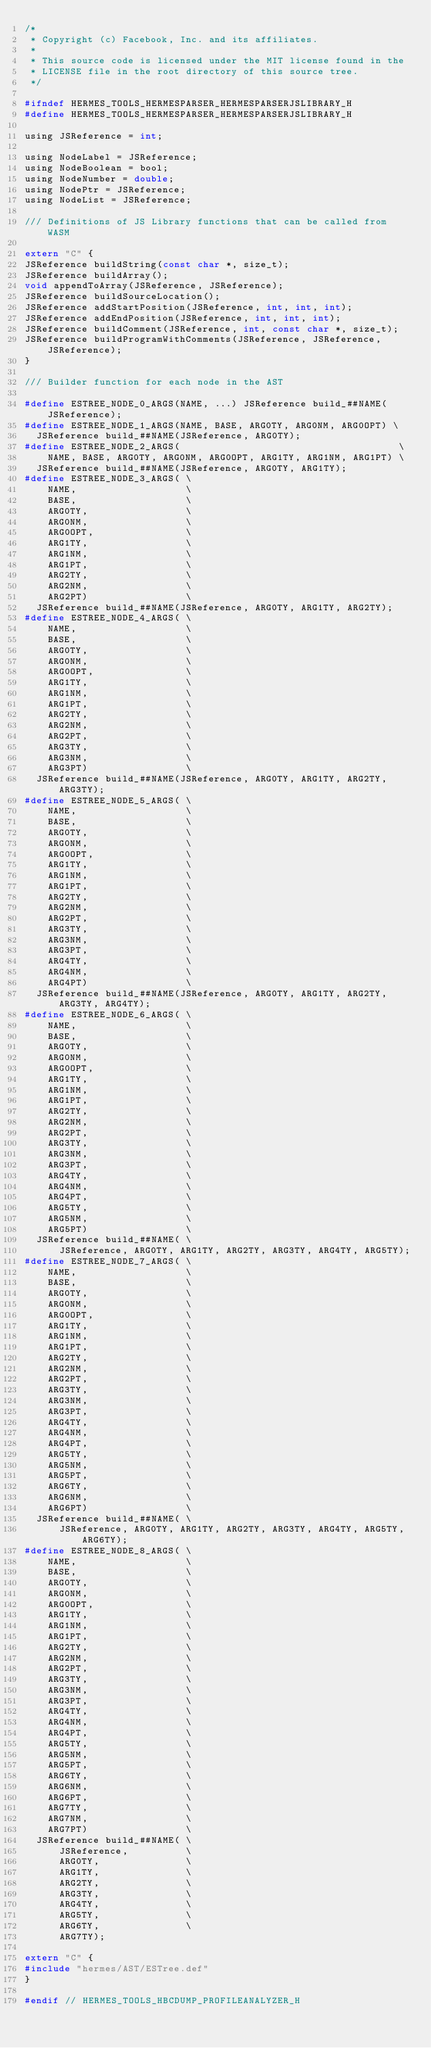Convert code to text. <code><loc_0><loc_0><loc_500><loc_500><_C_>/*
 * Copyright (c) Facebook, Inc. and its affiliates.
 *
 * This source code is licensed under the MIT license found in the
 * LICENSE file in the root directory of this source tree.
 */

#ifndef HERMES_TOOLS_HERMESPARSER_HERMESPARSERJSLIBRARY_H
#define HERMES_TOOLS_HERMESPARSER_HERMESPARSERJSLIBRARY_H

using JSReference = int;

using NodeLabel = JSReference;
using NodeBoolean = bool;
using NodeNumber = double;
using NodePtr = JSReference;
using NodeList = JSReference;

/// Definitions of JS Library functions that can be called from WASM

extern "C" {
JSReference buildString(const char *, size_t);
JSReference buildArray();
void appendToArray(JSReference, JSReference);
JSReference buildSourceLocation();
JSReference addStartPosition(JSReference, int, int, int);
JSReference addEndPosition(JSReference, int, int, int);
JSReference buildComment(JSReference, int, const char *, size_t);
JSReference buildProgramWithComments(JSReference, JSReference, JSReference);
}

/// Builder function for each node in the AST

#define ESTREE_NODE_0_ARGS(NAME, ...) JSReference build_##NAME(JSReference);
#define ESTREE_NODE_1_ARGS(NAME, BASE, ARG0TY, ARG0NM, ARG0OPT) \
  JSReference build_##NAME(JSReference, ARG0TY);
#define ESTREE_NODE_2_ARGS(                                      \
    NAME, BASE, ARG0TY, ARG0NM, ARG0OPT, ARG1TY, ARG1NM, ARG1PT) \
  JSReference build_##NAME(JSReference, ARG0TY, ARG1TY);
#define ESTREE_NODE_3_ARGS( \
    NAME,                   \
    BASE,                   \
    ARG0TY,                 \
    ARG0NM,                 \
    ARG0OPT,                \
    ARG1TY,                 \
    ARG1NM,                 \
    ARG1PT,                 \
    ARG2TY,                 \
    ARG2NM,                 \
    ARG2PT)                 \
  JSReference build_##NAME(JSReference, ARG0TY, ARG1TY, ARG2TY);
#define ESTREE_NODE_4_ARGS( \
    NAME,                   \
    BASE,                   \
    ARG0TY,                 \
    ARG0NM,                 \
    ARG0OPT,                \
    ARG1TY,                 \
    ARG1NM,                 \
    ARG1PT,                 \
    ARG2TY,                 \
    ARG2NM,                 \
    ARG2PT,                 \
    ARG3TY,                 \
    ARG3NM,                 \
    ARG3PT)                 \
  JSReference build_##NAME(JSReference, ARG0TY, ARG1TY, ARG2TY, ARG3TY);
#define ESTREE_NODE_5_ARGS( \
    NAME,                   \
    BASE,                   \
    ARG0TY,                 \
    ARG0NM,                 \
    ARG0OPT,                \
    ARG1TY,                 \
    ARG1NM,                 \
    ARG1PT,                 \
    ARG2TY,                 \
    ARG2NM,                 \
    ARG2PT,                 \
    ARG3TY,                 \
    ARG3NM,                 \
    ARG3PT,                 \
    ARG4TY,                 \
    ARG4NM,                 \
    ARG4PT)                 \
  JSReference build_##NAME(JSReference, ARG0TY, ARG1TY, ARG2TY, ARG3TY, ARG4TY);
#define ESTREE_NODE_6_ARGS( \
    NAME,                   \
    BASE,                   \
    ARG0TY,                 \
    ARG0NM,                 \
    ARG0OPT,                \
    ARG1TY,                 \
    ARG1NM,                 \
    ARG1PT,                 \
    ARG2TY,                 \
    ARG2NM,                 \
    ARG2PT,                 \
    ARG3TY,                 \
    ARG3NM,                 \
    ARG3PT,                 \
    ARG4TY,                 \
    ARG4NM,                 \
    ARG4PT,                 \
    ARG5TY,                 \
    ARG5NM,                 \
    ARG5PT)                 \
  JSReference build_##NAME( \
      JSReference, ARG0TY, ARG1TY, ARG2TY, ARG3TY, ARG4TY, ARG5TY);
#define ESTREE_NODE_7_ARGS( \
    NAME,                   \
    BASE,                   \
    ARG0TY,                 \
    ARG0NM,                 \
    ARG0OPT,                \
    ARG1TY,                 \
    ARG1NM,                 \
    ARG1PT,                 \
    ARG2TY,                 \
    ARG2NM,                 \
    ARG2PT,                 \
    ARG3TY,                 \
    ARG3NM,                 \
    ARG3PT,                 \
    ARG4TY,                 \
    ARG4NM,                 \
    ARG4PT,                 \
    ARG5TY,                 \
    ARG5NM,                 \
    ARG5PT,                 \
    ARG6TY,                 \
    ARG6NM,                 \
    ARG6PT)                 \
  JSReference build_##NAME( \
      JSReference, ARG0TY, ARG1TY, ARG2TY, ARG3TY, ARG4TY, ARG5TY, ARG6TY);
#define ESTREE_NODE_8_ARGS( \
    NAME,                   \
    BASE,                   \
    ARG0TY,                 \
    ARG0NM,                 \
    ARG0OPT,                \
    ARG1TY,                 \
    ARG1NM,                 \
    ARG1PT,                 \
    ARG2TY,                 \
    ARG2NM,                 \
    ARG2PT,                 \
    ARG3TY,                 \
    ARG3NM,                 \
    ARG3PT,                 \
    ARG4TY,                 \
    ARG4NM,                 \
    ARG4PT,                 \
    ARG5TY,                 \
    ARG5NM,                 \
    ARG5PT,                 \
    ARG6TY,                 \
    ARG6NM,                 \
    ARG6PT,                 \
    ARG7TY,                 \
    ARG7NM,                 \
    ARG7PT)                 \
  JSReference build_##NAME( \
      JSReference,          \
      ARG0TY,               \
      ARG1TY,               \
      ARG2TY,               \
      ARG3TY,               \
      ARG4TY,               \
      ARG5TY,               \
      ARG6TY,               \
      ARG7TY);

extern "C" {
#include "hermes/AST/ESTree.def"
}

#endif // HERMES_TOOLS_HBCDUMP_PROFILEANALYZER_H
</code> 